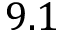Convert formula to latex. <formula><loc_0><loc_0><loc_500><loc_500>9 . 1</formula> 